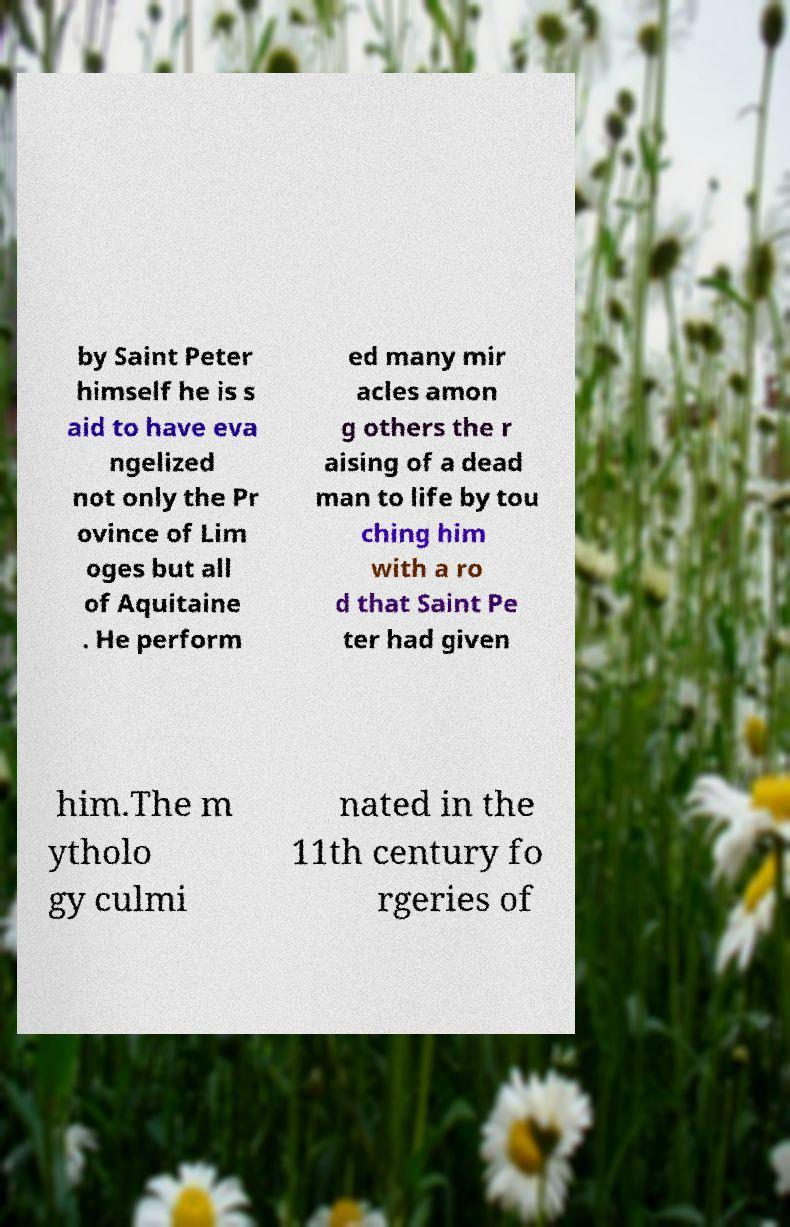Please read and relay the text visible in this image. What does it say? by Saint Peter himself he is s aid to have eva ngelized not only the Pr ovince of Lim oges but all of Aquitaine . He perform ed many mir acles amon g others the r aising of a dead man to life by tou ching him with a ro d that Saint Pe ter had given him.The m ytholo gy culmi nated in the 11th century fo rgeries of 